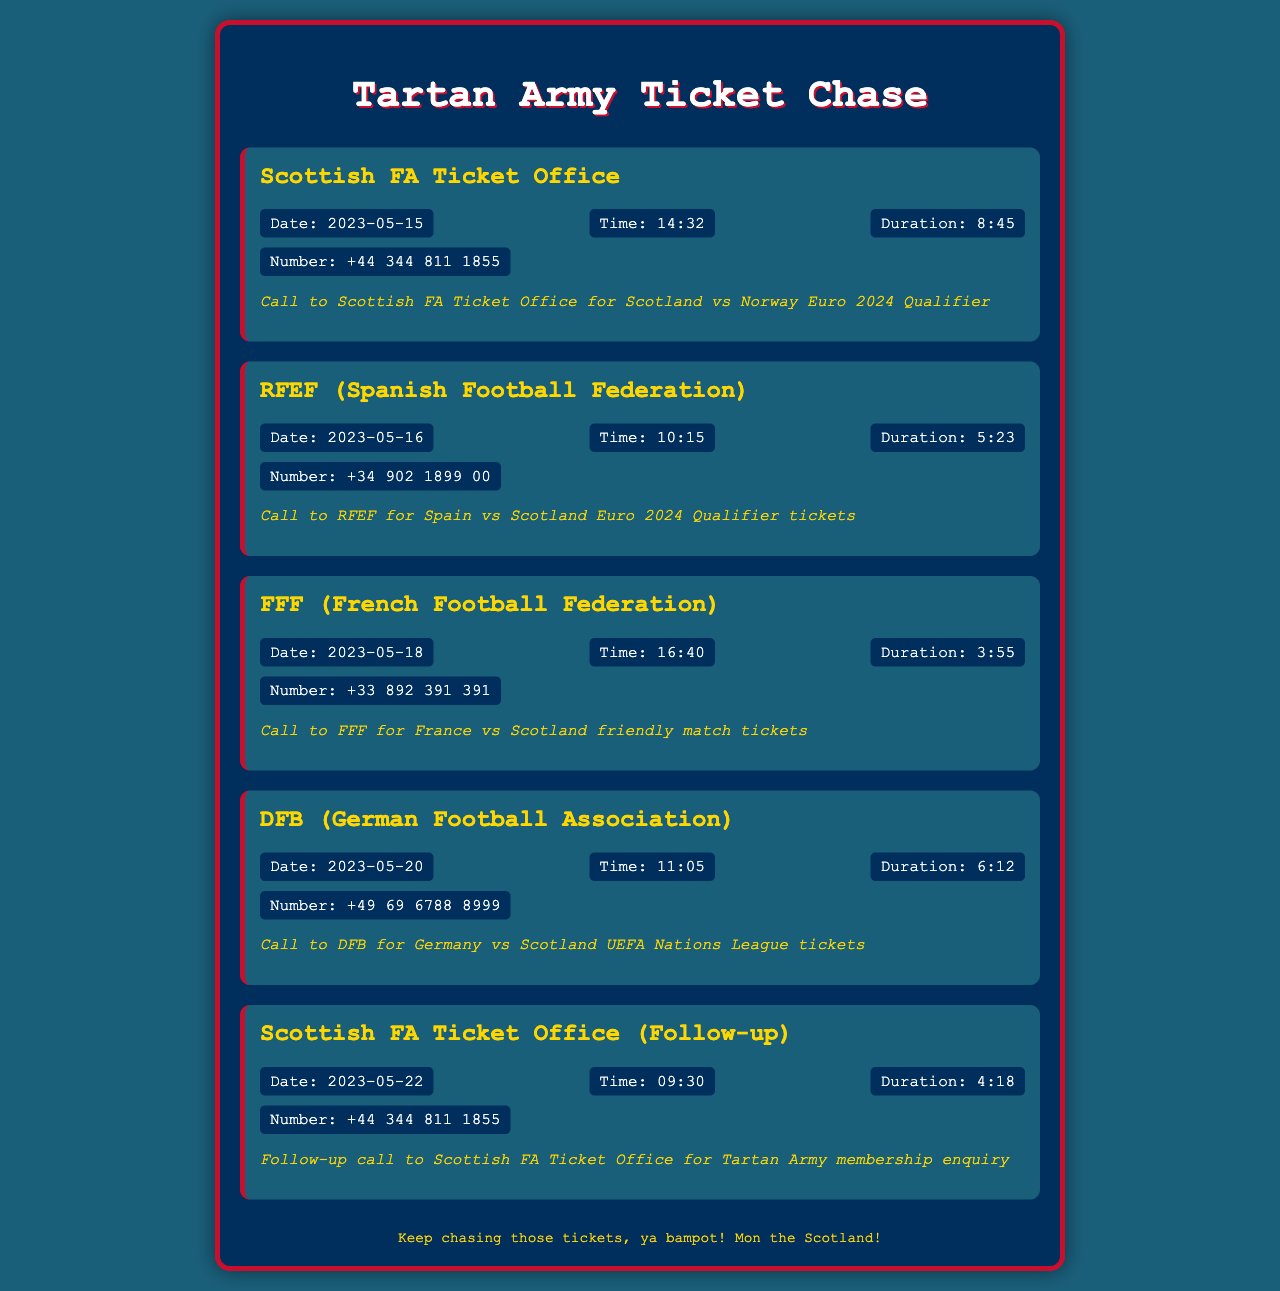What is the date of the call to the Scottish FA Ticket Office? The call to the Scottish FA Ticket Office took place on May 15, 2023.
Answer: May 15, 2023 What is the duration of the call to FFF? The call to FFF lasted for 3 minutes and 55 seconds.
Answer: 3:55 What is the phone number for RFEF? The phone number for RFEF is +34 902 1899 00.
Answer: +34 902 1899 00 What was the purpose of the follow-up call to the Scottish FA Ticket Office? The follow-up call was for a Tartan Army membership enquiry.
Answer: Tartan Army membership enquiry Which football federation was contacted for tickets to the Germany vs Scotland match? The DFB (German Football Association) was contacted for tickets.
Answer: DFB How many calls were made to the Scottish FA Ticket Office? Two calls were made to the Scottish FA Ticket Office.
Answer: Two What is the time of the call to the FFF? The call to the FFF was made at 16:40.
Answer: 16:40 What was the first call regarding? The first call was regarding the Scotland vs Norway Euro 2024 Qualifier.
Answer: Scotland vs Norway Euro 2024 Qualifier What color is the background of the document? The background color of the document is #1A5F7A.
Answer: #1A5F7A 